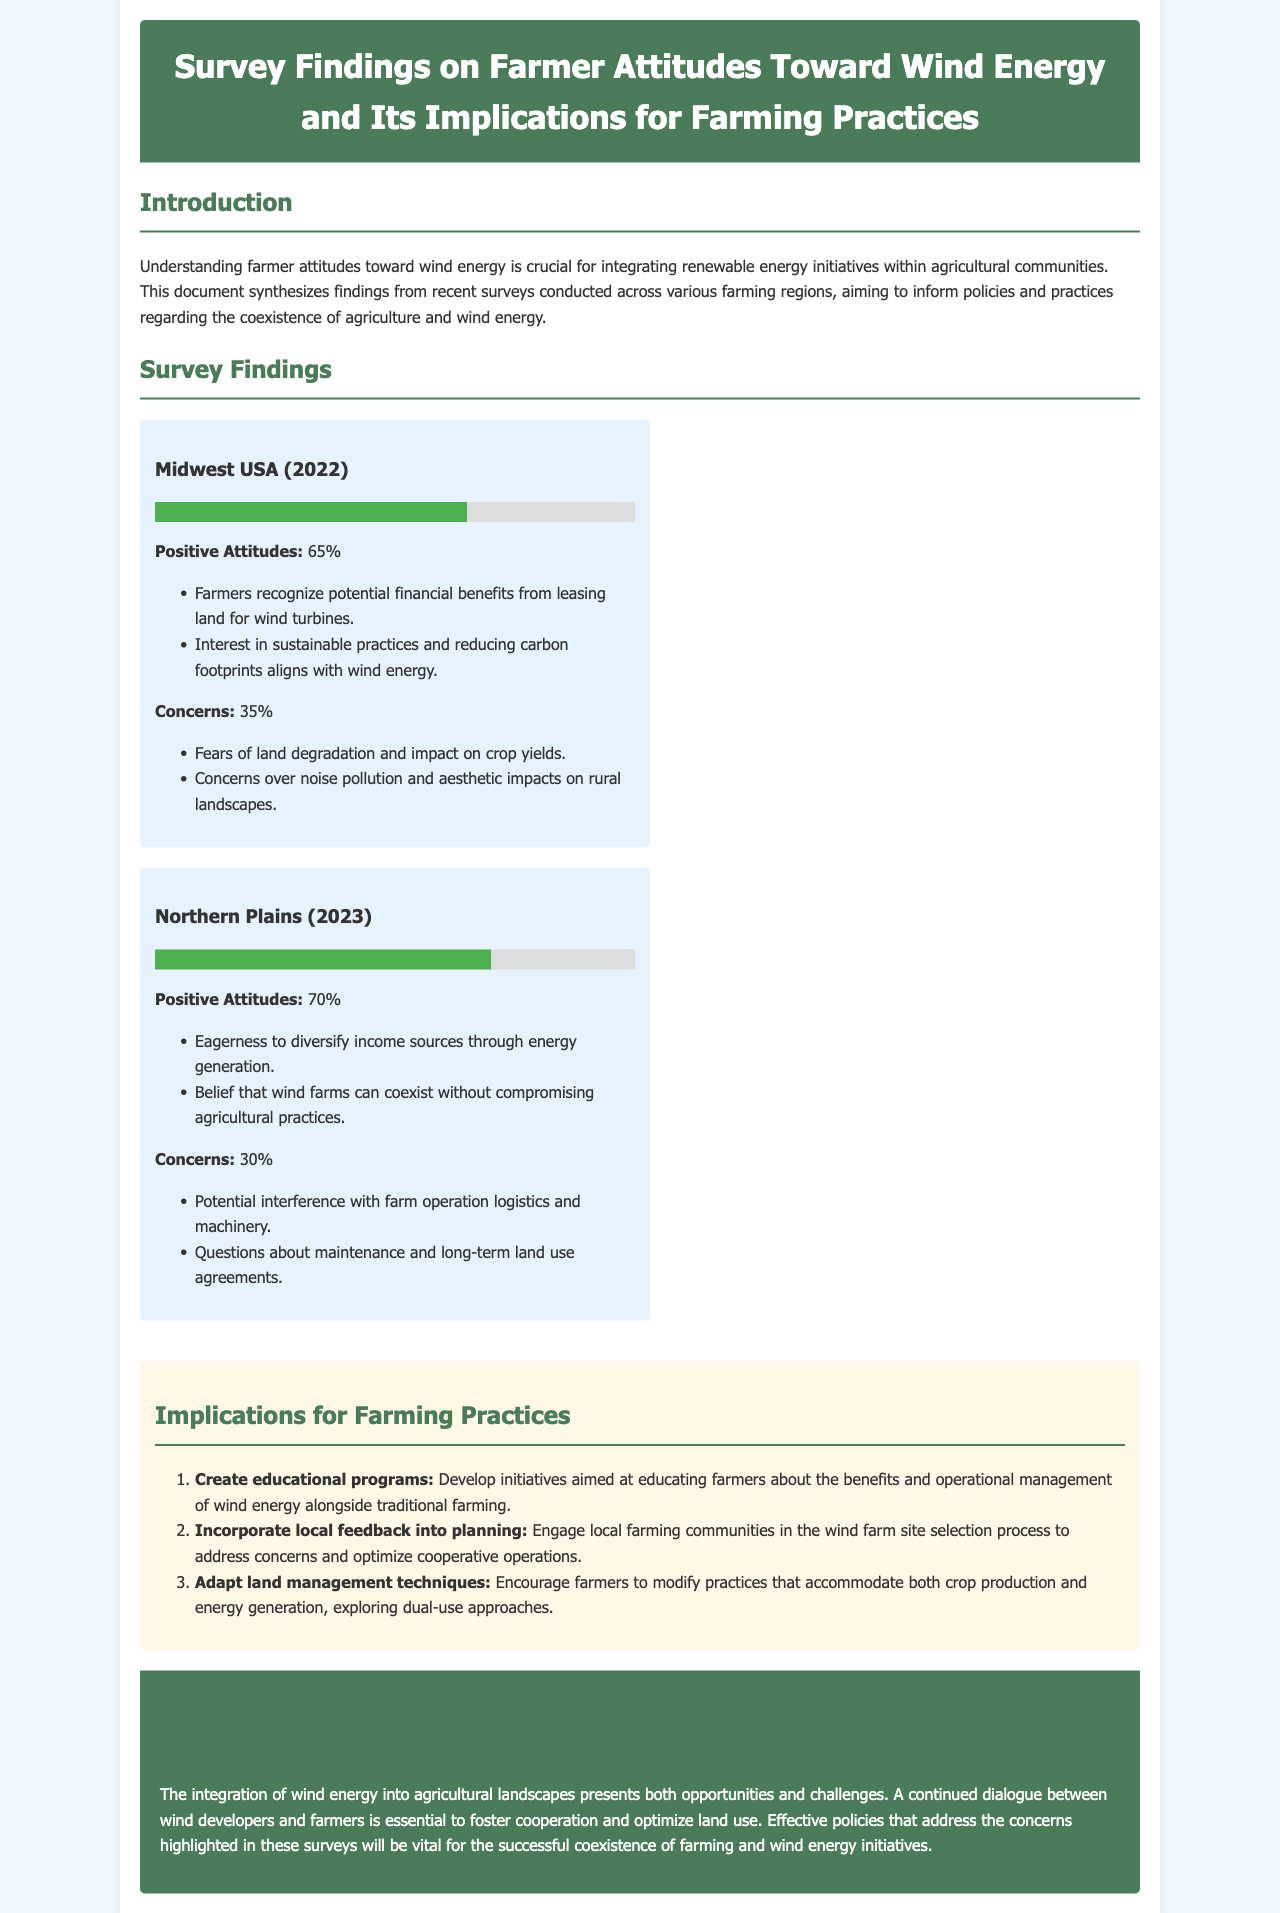What percentage of Midwest USA farmers have positive attitudes toward wind energy? The document states that 65% of farmers in the Midwest USA have positive attitudes toward wind energy.
Answer: 65% What is one benefit farmers see in leasing land for wind turbines? The document mentions that farmers recognize potential financial benefits from leasing land for wind turbines.
Answer: Financial benefits What year was the survey conducted in the Northern Plains? The document indicates that the survey in the Northern Plains was conducted in 2023.
Answer: 2023 What is the main concern of Midwest farmers regarding wind energy? The document outlines that one of the primary concerns is fears of land degradation and impact on crop yields.
Answer: Land degradation What is one implication suggested for farming practices? The document suggests creating educational programs aimed at educating farmers about wind energy in conjunction with traditional farming.
Answer: Create educational programs What percentage of Northern Plains farmers have positive attitudes toward wind energy? The document states that 70% of farmers in the Northern Plains have positive attitudes toward wind energy.
Answer: 70% What do farmers in the Northern Plains believe regarding wind farms? The document highlights that farmers believe wind farms can coexist without compromising agricultural practices.
Answer: Coexistence What type of initiatives does the document recommend for farmer education? The document recommends developing initiatives aimed at educating farmers about the benefits and operational management of wind energy.
Answer: Educational programs 